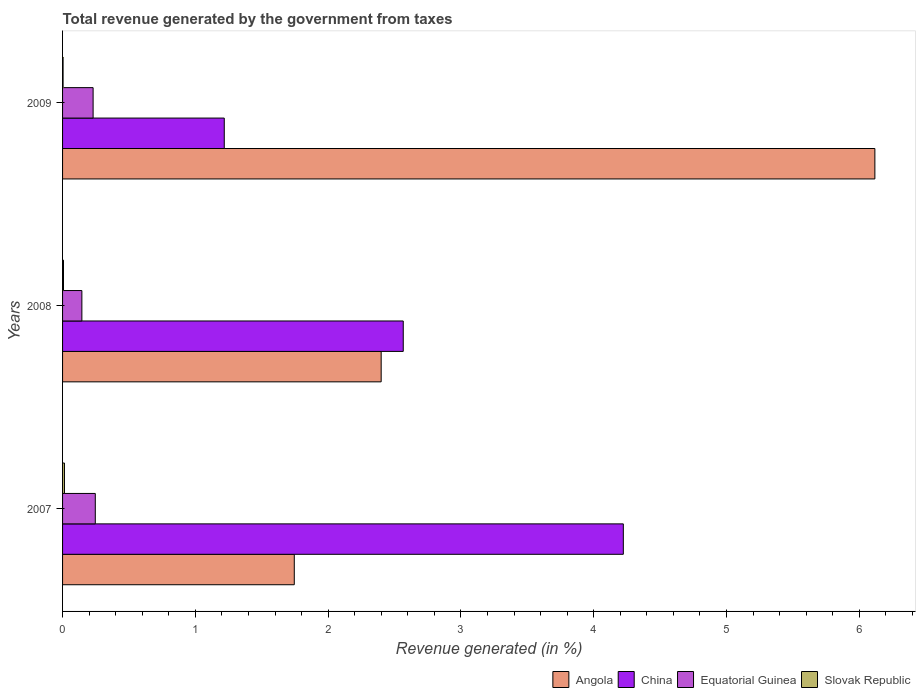Are the number of bars per tick equal to the number of legend labels?
Offer a terse response. Yes. What is the total revenue generated in Angola in 2007?
Make the answer very short. 1.75. Across all years, what is the maximum total revenue generated in Angola?
Ensure brevity in your answer.  6.12. Across all years, what is the minimum total revenue generated in Angola?
Give a very brief answer. 1.75. What is the total total revenue generated in Equatorial Guinea in the graph?
Your answer should be compact. 0.62. What is the difference between the total revenue generated in Angola in 2007 and that in 2008?
Your answer should be very brief. -0.65. What is the difference between the total revenue generated in China in 2008 and the total revenue generated in Angola in 2007?
Keep it short and to the point. 0.82. What is the average total revenue generated in Equatorial Guinea per year?
Keep it short and to the point. 0.21. In the year 2007, what is the difference between the total revenue generated in Equatorial Guinea and total revenue generated in Angola?
Make the answer very short. -1.5. What is the ratio of the total revenue generated in China in 2008 to that in 2009?
Your answer should be very brief. 2.11. Is the difference between the total revenue generated in Equatorial Guinea in 2008 and 2009 greater than the difference between the total revenue generated in Angola in 2008 and 2009?
Ensure brevity in your answer.  Yes. What is the difference between the highest and the second highest total revenue generated in Equatorial Guinea?
Ensure brevity in your answer.  0.02. What is the difference between the highest and the lowest total revenue generated in Equatorial Guinea?
Your response must be concise. 0.1. What does the 1st bar from the top in 2009 represents?
Your answer should be very brief. Slovak Republic. What does the 3rd bar from the bottom in 2007 represents?
Make the answer very short. Equatorial Guinea. Is it the case that in every year, the sum of the total revenue generated in Equatorial Guinea and total revenue generated in China is greater than the total revenue generated in Slovak Republic?
Offer a very short reply. Yes. Are all the bars in the graph horizontal?
Make the answer very short. Yes. How many years are there in the graph?
Ensure brevity in your answer.  3. What is the difference between two consecutive major ticks on the X-axis?
Keep it short and to the point. 1. How many legend labels are there?
Provide a succinct answer. 4. What is the title of the graph?
Give a very brief answer. Total revenue generated by the government from taxes. Does "Senegal" appear as one of the legend labels in the graph?
Your response must be concise. No. What is the label or title of the X-axis?
Make the answer very short. Revenue generated (in %). What is the label or title of the Y-axis?
Offer a very short reply. Years. What is the Revenue generated (in %) of Angola in 2007?
Keep it short and to the point. 1.75. What is the Revenue generated (in %) in China in 2007?
Ensure brevity in your answer.  4.22. What is the Revenue generated (in %) in Equatorial Guinea in 2007?
Offer a terse response. 0.25. What is the Revenue generated (in %) of Slovak Republic in 2007?
Provide a short and direct response. 0.01. What is the Revenue generated (in %) in Angola in 2008?
Your answer should be compact. 2.4. What is the Revenue generated (in %) in China in 2008?
Give a very brief answer. 2.57. What is the Revenue generated (in %) of Equatorial Guinea in 2008?
Provide a succinct answer. 0.15. What is the Revenue generated (in %) in Slovak Republic in 2008?
Your answer should be very brief. 0.01. What is the Revenue generated (in %) in Angola in 2009?
Give a very brief answer. 6.12. What is the Revenue generated (in %) of China in 2009?
Offer a very short reply. 1.22. What is the Revenue generated (in %) in Equatorial Guinea in 2009?
Offer a terse response. 0.23. What is the Revenue generated (in %) in Slovak Republic in 2009?
Ensure brevity in your answer.  0. Across all years, what is the maximum Revenue generated (in %) of Angola?
Give a very brief answer. 6.12. Across all years, what is the maximum Revenue generated (in %) of China?
Keep it short and to the point. 4.22. Across all years, what is the maximum Revenue generated (in %) in Equatorial Guinea?
Provide a succinct answer. 0.25. Across all years, what is the maximum Revenue generated (in %) in Slovak Republic?
Ensure brevity in your answer.  0.01. Across all years, what is the minimum Revenue generated (in %) in Angola?
Provide a succinct answer. 1.75. Across all years, what is the minimum Revenue generated (in %) in China?
Your answer should be compact. 1.22. Across all years, what is the minimum Revenue generated (in %) of Equatorial Guinea?
Your answer should be very brief. 0.15. Across all years, what is the minimum Revenue generated (in %) in Slovak Republic?
Your response must be concise. 0. What is the total Revenue generated (in %) in Angola in the graph?
Keep it short and to the point. 10.26. What is the total Revenue generated (in %) of China in the graph?
Provide a short and direct response. 8.01. What is the total Revenue generated (in %) in Equatorial Guinea in the graph?
Your response must be concise. 0.62. What is the total Revenue generated (in %) in Slovak Republic in the graph?
Your answer should be very brief. 0.03. What is the difference between the Revenue generated (in %) in Angola in 2007 and that in 2008?
Provide a short and direct response. -0.65. What is the difference between the Revenue generated (in %) in China in 2007 and that in 2008?
Your answer should be very brief. 1.66. What is the difference between the Revenue generated (in %) in Equatorial Guinea in 2007 and that in 2008?
Make the answer very short. 0.1. What is the difference between the Revenue generated (in %) in Slovak Republic in 2007 and that in 2008?
Ensure brevity in your answer.  0.01. What is the difference between the Revenue generated (in %) in Angola in 2007 and that in 2009?
Keep it short and to the point. -4.37. What is the difference between the Revenue generated (in %) of China in 2007 and that in 2009?
Your answer should be very brief. 3.01. What is the difference between the Revenue generated (in %) in Equatorial Guinea in 2007 and that in 2009?
Provide a succinct answer. 0.02. What is the difference between the Revenue generated (in %) in Slovak Republic in 2007 and that in 2009?
Your answer should be very brief. 0.01. What is the difference between the Revenue generated (in %) of Angola in 2008 and that in 2009?
Keep it short and to the point. -3.72. What is the difference between the Revenue generated (in %) in China in 2008 and that in 2009?
Your response must be concise. 1.35. What is the difference between the Revenue generated (in %) of Equatorial Guinea in 2008 and that in 2009?
Make the answer very short. -0.08. What is the difference between the Revenue generated (in %) of Slovak Republic in 2008 and that in 2009?
Your response must be concise. 0. What is the difference between the Revenue generated (in %) of Angola in 2007 and the Revenue generated (in %) of China in 2008?
Make the answer very short. -0.82. What is the difference between the Revenue generated (in %) in Angola in 2007 and the Revenue generated (in %) in Equatorial Guinea in 2008?
Offer a very short reply. 1.6. What is the difference between the Revenue generated (in %) in Angola in 2007 and the Revenue generated (in %) in Slovak Republic in 2008?
Give a very brief answer. 1.74. What is the difference between the Revenue generated (in %) in China in 2007 and the Revenue generated (in %) in Equatorial Guinea in 2008?
Provide a succinct answer. 4.08. What is the difference between the Revenue generated (in %) of China in 2007 and the Revenue generated (in %) of Slovak Republic in 2008?
Your answer should be compact. 4.22. What is the difference between the Revenue generated (in %) in Equatorial Guinea in 2007 and the Revenue generated (in %) in Slovak Republic in 2008?
Provide a succinct answer. 0.24. What is the difference between the Revenue generated (in %) in Angola in 2007 and the Revenue generated (in %) in China in 2009?
Your answer should be compact. 0.53. What is the difference between the Revenue generated (in %) of Angola in 2007 and the Revenue generated (in %) of Equatorial Guinea in 2009?
Provide a short and direct response. 1.51. What is the difference between the Revenue generated (in %) of Angola in 2007 and the Revenue generated (in %) of Slovak Republic in 2009?
Provide a succinct answer. 1.74. What is the difference between the Revenue generated (in %) in China in 2007 and the Revenue generated (in %) in Equatorial Guinea in 2009?
Provide a short and direct response. 3.99. What is the difference between the Revenue generated (in %) in China in 2007 and the Revenue generated (in %) in Slovak Republic in 2009?
Provide a short and direct response. 4.22. What is the difference between the Revenue generated (in %) of Equatorial Guinea in 2007 and the Revenue generated (in %) of Slovak Republic in 2009?
Make the answer very short. 0.24. What is the difference between the Revenue generated (in %) in Angola in 2008 and the Revenue generated (in %) in China in 2009?
Keep it short and to the point. 1.18. What is the difference between the Revenue generated (in %) of Angola in 2008 and the Revenue generated (in %) of Equatorial Guinea in 2009?
Offer a very short reply. 2.17. What is the difference between the Revenue generated (in %) in Angola in 2008 and the Revenue generated (in %) in Slovak Republic in 2009?
Your response must be concise. 2.4. What is the difference between the Revenue generated (in %) in China in 2008 and the Revenue generated (in %) in Equatorial Guinea in 2009?
Your answer should be compact. 2.34. What is the difference between the Revenue generated (in %) of China in 2008 and the Revenue generated (in %) of Slovak Republic in 2009?
Keep it short and to the point. 2.56. What is the difference between the Revenue generated (in %) in Equatorial Guinea in 2008 and the Revenue generated (in %) in Slovak Republic in 2009?
Ensure brevity in your answer.  0.14. What is the average Revenue generated (in %) in Angola per year?
Ensure brevity in your answer.  3.42. What is the average Revenue generated (in %) of China per year?
Make the answer very short. 2.67. What is the average Revenue generated (in %) of Equatorial Guinea per year?
Offer a terse response. 0.21. What is the average Revenue generated (in %) of Slovak Republic per year?
Your answer should be very brief. 0.01. In the year 2007, what is the difference between the Revenue generated (in %) of Angola and Revenue generated (in %) of China?
Your response must be concise. -2.48. In the year 2007, what is the difference between the Revenue generated (in %) in Angola and Revenue generated (in %) in Equatorial Guinea?
Your answer should be compact. 1.5. In the year 2007, what is the difference between the Revenue generated (in %) of Angola and Revenue generated (in %) of Slovak Republic?
Provide a short and direct response. 1.73. In the year 2007, what is the difference between the Revenue generated (in %) in China and Revenue generated (in %) in Equatorial Guinea?
Your response must be concise. 3.98. In the year 2007, what is the difference between the Revenue generated (in %) of China and Revenue generated (in %) of Slovak Republic?
Provide a succinct answer. 4.21. In the year 2007, what is the difference between the Revenue generated (in %) of Equatorial Guinea and Revenue generated (in %) of Slovak Republic?
Offer a terse response. 0.23. In the year 2008, what is the difference between the Revenue generated (in %) in Angola and Revenue generated (in %) in China?
Provide a succinct answer. -0.17. In the year 2008, what is the difference between the Revenue generated (in %) in Angola and Revenue generated (in %) in Equatorial Guinea?
Keep it short and to the point. 2.25. In the year 2008, what is the difference between the Revenue generated (in %) of Angola and Revenue generated (in %) of Slovak Republic?
Make the answer very short. 2.39. In the year 2008, what is the difference between the Revenue generated (in %) in China and Revenue generated (in %) in Equatorial Guinea?
Give a very brief answer. 2.42. In the year 2008, what is the difference between the Revenue generated (in %) of China and Revenue generated (in %) of Slovak Republic?
Your answer should be very brief. 2.56. In the year 2008, what is the difference between the Revenue generated (in %) of Equatorial Guinea and Revenue generated (in %) of Slovak Republic?
Provide a succinct answer. 0.14. In the year 2009, what is the difference between the Revenue generated (in %) of Angola and Revenue generated (in %) of China?
Give a very brief answer. 4.9. In the year 2009, what is the difference between the Revenue generated (in %) of Angola and Revenue generated (in %) of Equatorial Guinea?
Your response must be concise. 5.89. In the year 2009, what is the difference between the Revenue generated (in %) in Angola and Revenue generated (in %) in Slovak Republic?
Offer a very short reply. 6.11. In the year 2009, what is the difference between the Revenue generated (in %) in China and Revenue generated (in %) in Slovak Republic?
Your answer should be compact. 1.21. In the year 2009, what is the difference between the Revenue generated (in %) of Equatorial Guinea and Revenue generated (in %) of Slovak Republic?
Your answer should be compact. 0.23. What is the ratio of the Revenue generated (in %) in Angola in 2007 to that in 2008?
Provide a short and direct response. 0.73. What is the ratio of the Revenue generated (in %) in China in 2007 to that in 2008?
Your answer should be very brief. 1.65. What is the ratio of the Revenue generated (in %) in Equatorial Guinea in 2007 to that in 2008?
Make the answer very short. 1.69. What is the ratio of the Revenue generated (in %) in Slovak Republic in 2007 to that in 2008?
Keep it short and to the point. 2.04. What is the ratio of the Revenue generated (in %) of Angola in 2007 to that in 2009?
Your answer should be compact. 0.29. What is the ratio of the Revenue generated (in %) of China in 2007 to that in 2009?
Your response must be concise. 3.47. What is the ratio of the Revenue generated (in %) in Equatorial Guinea in 2007 to that in 2009?
Offer a very short reply. 1.07. What is the ratio of the Revenue generated (in %) of Slovak Republic in 2007 to that in 2009?
Keep it short and to the point. 3.67. What is the ratio of the Revenue generated (in %) in Angola in 2008 to that in 2009?
Ensure brevity in your answer.  0.39. What is the ratio of the Revenue generated (in %) in China in 2008 to that in 2009?
Give a very brief answer. 2.11. What is the ratio of the Revenue generated (in %) of Equatorial Guinea in 2008 to that in 2009?
Make the answer very short. 0.63. What is the ratio of the Revenue generated (in %) in Slovak Republic in 2008 to that in 2009?
Give a very brief answer. 1.8. What is the difference between the highest and the second highest Revenue generated (in %) of Angola?
Give a very brief answer. 3.72. What is the difference between the highest and the second highest Revenue generated (in %) in China?
Your answer should be very brief. 1.66. What is the difference between the highest and the second highest Revenue generated (in %) in Equatorial Guinea?
Give a very brief answer. 0.02. What is the difference between the highest and the second highest Revenue generated (in %) of Slovak Republic?
Your response must be concise. 0.01. What is the difference between the highest and the lowest Revenue generated (in %) of Angola?
Offer a very short reply. 4.37. What is the difference between the highest and the lowest Revenue generated (in %) in China?
Your response must be concise. 3.01. What is the difference between the highest and the lowest Revenue generated (in %) in Equatorial Guinea?
Ensure brevity in your answer.  0.1. What is the difference between the highest and the lowest Revenue generated (in %) of Slovak Republic?
Your response must be concise. 0.01. 